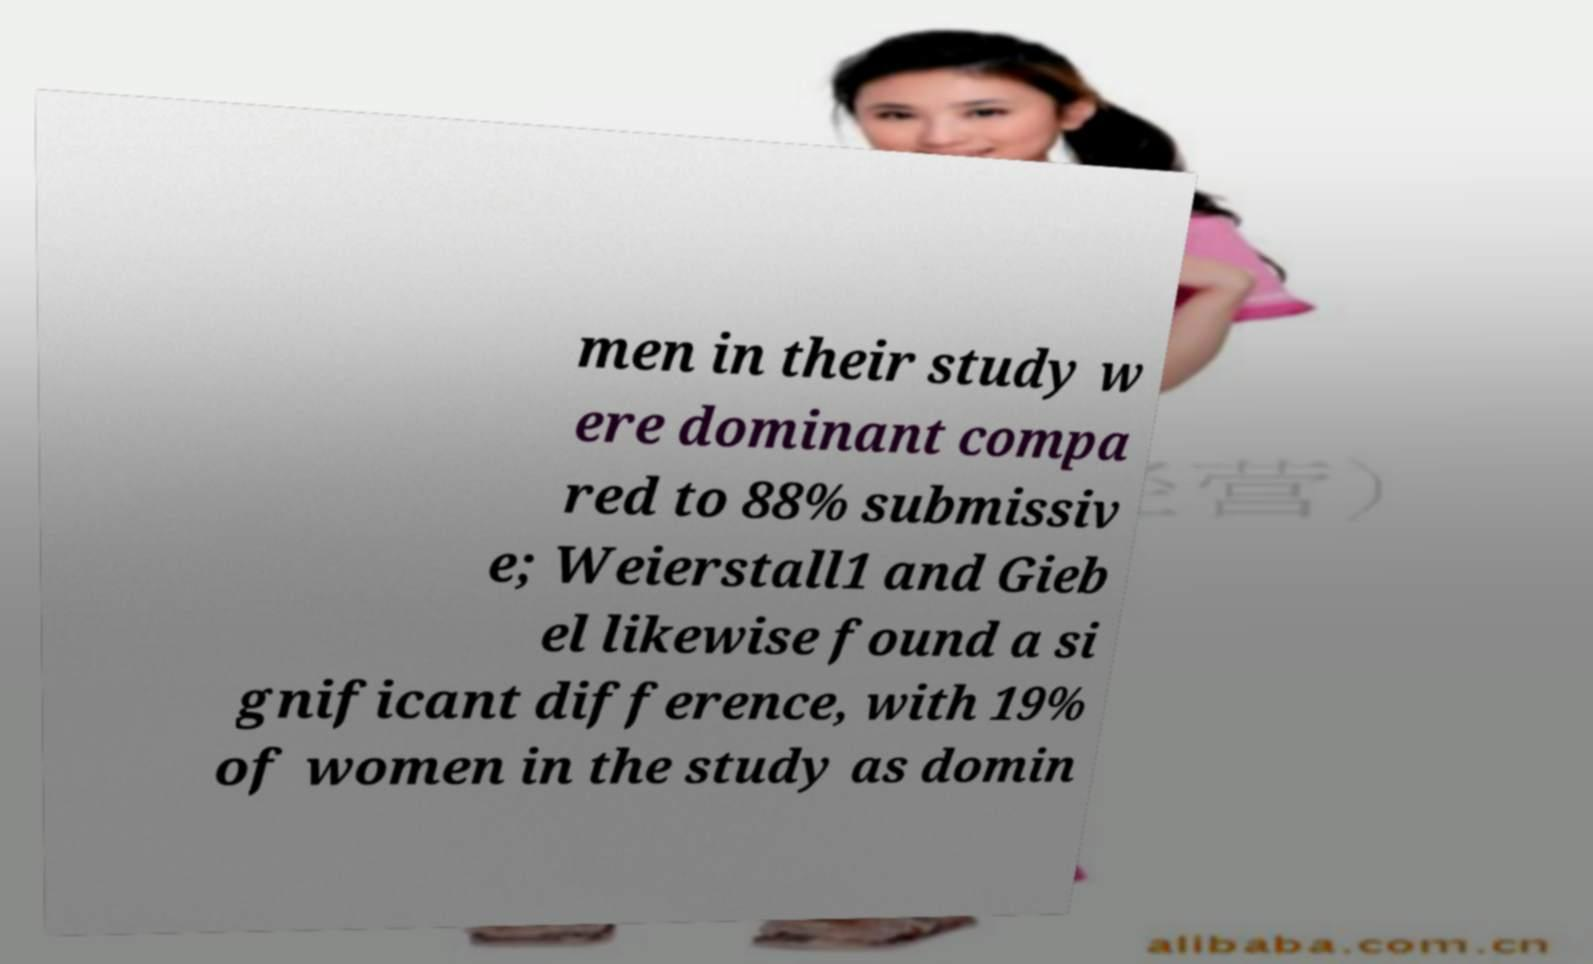What messages or text are displayed in this image? I need them in a readable, typed format. men in their study w ere dominant compa red to 88% submissiv e; Weierstall1 and Gieb el likewise found a si gnificant difference, with 19% of women in the study as domin 